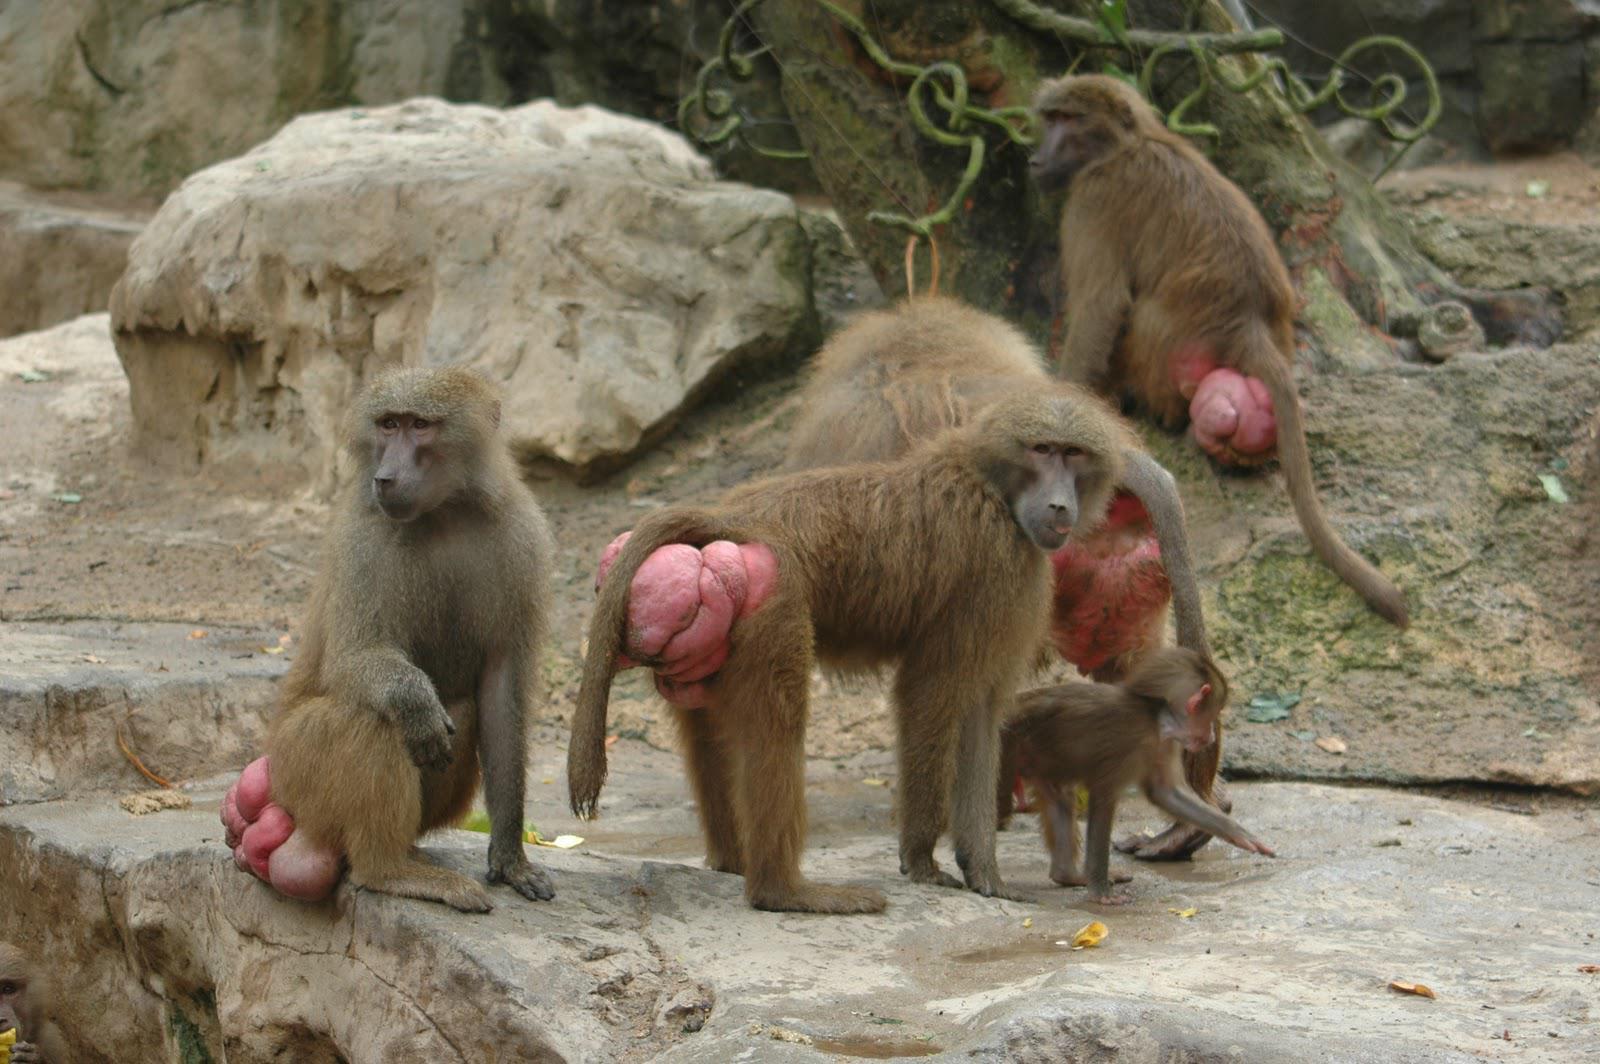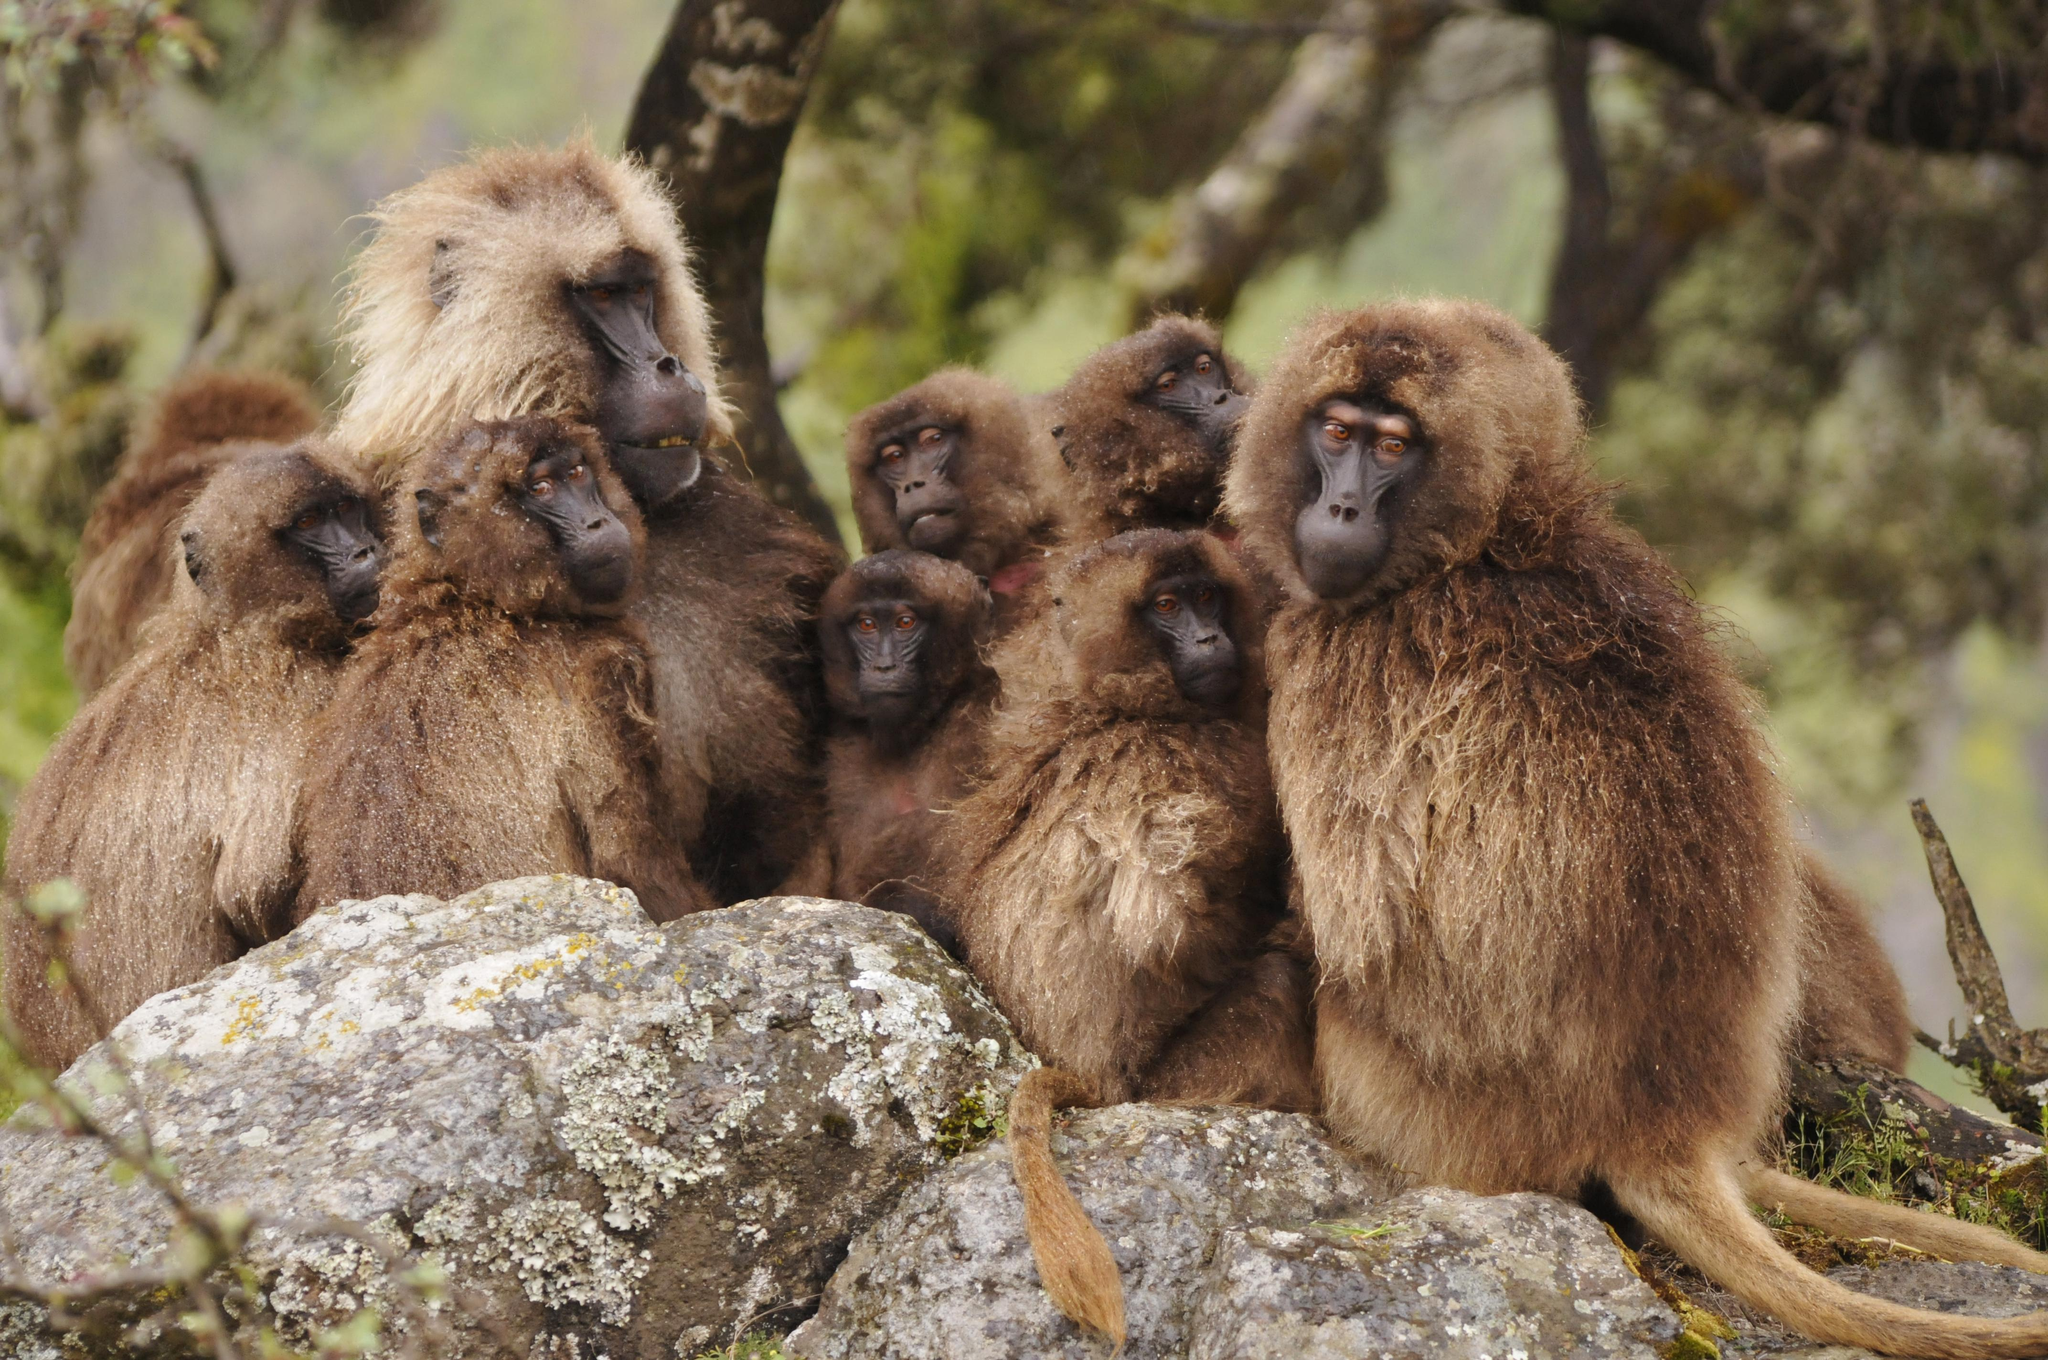The first image is the image on the left, the second image is the image on the right. Assess this claim about the two images: "The animals in the image on the left are near a body of water.". Correct or not? Answer yes or no. No. The first image is the image on the left, the second image is the image on the right. For the images displayed, is the sentence "Right image shows a group of baboons gathered but not closely huddled in a field with plant life present." factually correct? Answer yes or no. No. 